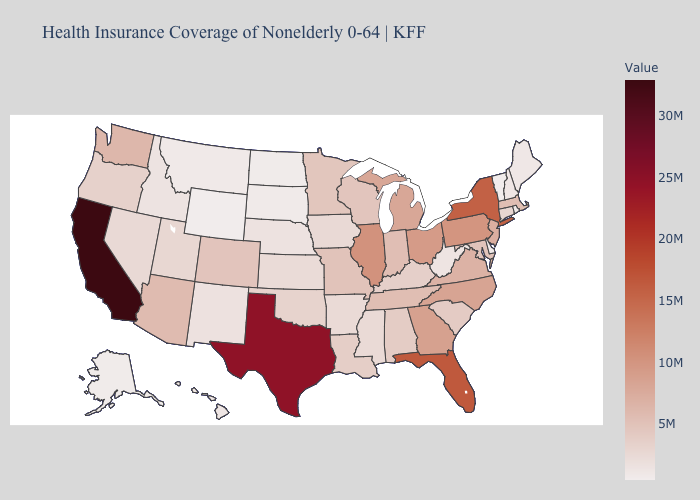Which states have the lowest value in the South?
Be succinct. Delaware. Does the map have missing data?
Keep it brief. No. Which states have the lowest value in the Northeast?
Give a very brief answer. Vermont. Which states have the lowest value in the USA?
Write a very short answer. Wyoming. Which states have the highest value in the USA?
Concise answer only. California. Does Texas have the highest value in the South?
Give a very brief answer. Yes. Among the states that border New Mexico , does Texas have the highest value?
Keep it brief. Yes. 